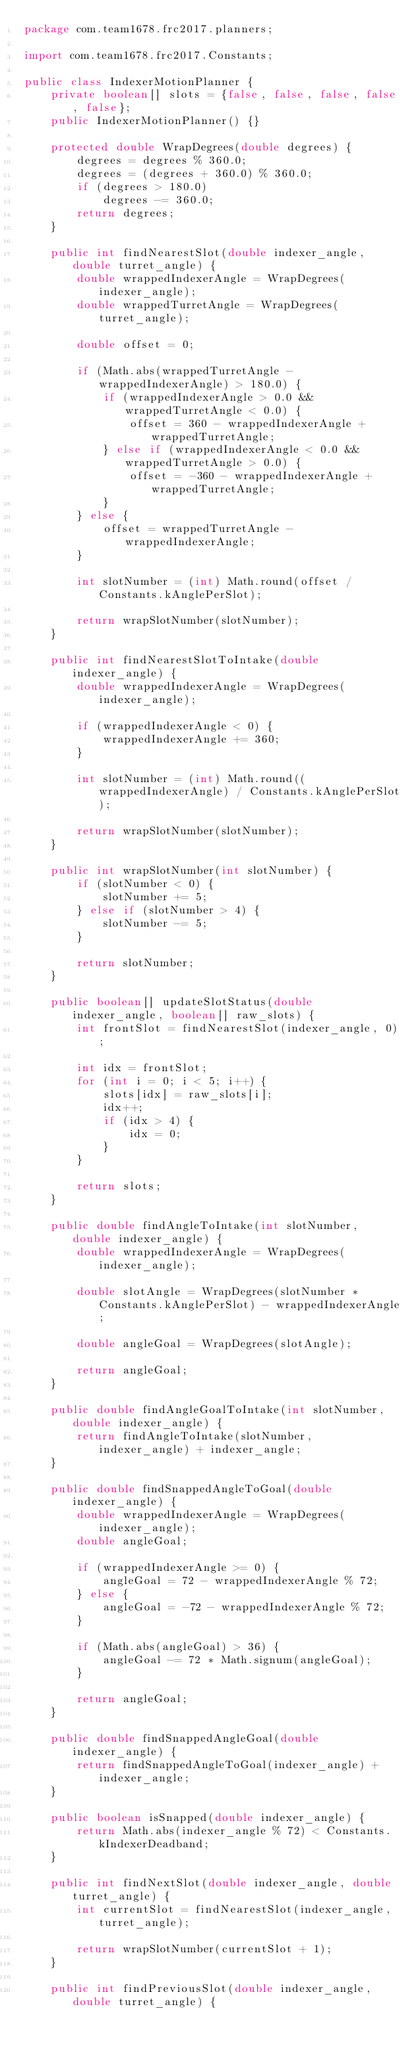Convert code to text. <code><loc_0><loc_0><loc_500><loc_500><_Java_>package com.team1678.frc2017.planners;

import com.team1678.frc2017.Constants;

public class IndexerMotionPlanner {
    private boolean[] slots = {false, false, false, false, false};
    public IndexerMotionPlanner() {}

    protected double WrapDegrees(double degrees) {
        degrees = degrees % 360.0;
        degrees = (degrees + 360.0) % 360.0;
        if (degrees > 180.0)
            degrees -= 360.0;
        return degrees;
    }

    public int findNearestSlot(double indexer_angle, double turret_angle) {
        double wrappedIndexerAngle = WrapDegrees(indexer_angle);
        double wrappedTurretAngle = WrapDegrees(turret_angle);

        double offset = 0; 
        
        if (Math.abs(wrappedTurretAngle - wrappedIndexerAngle) > 180.0) {
            if (wrappedIndexerAngle > 0.0 && wrappedTurretAngle < 0.0) {
                offset = 360 - wrappedIndexerAngle + wrappedTurretAngle;
            } else if (wrappedIndexerAngle < 0.0 && wrappedTurretAngle > 0.0) {
                offset = -360 - wrappedIndexerAngle + wrappedTurretAngle;
            }
        } else {
            offset = wrappedTurretAngle - wrappedIndexerAngle;
        }

        int slotNumber = (int) Math.round(offset / Constants.kAnglePerSlot);

        return wrapSlotNumber(slotNumber);
    }

    public int findNearestSlotToIntake(double indexer_angle) {
        double wrappedIndexerAngle = WrapDegrees(indexer_angle);

        if (wrappedIndexerAngle < 0) {
            wrappedIndexerAngle += 360;
        }

        int slotNumber = (int) Math.round((wrappedIndexerAngle) / Constants.kAnglePerSlot);

        return wrapSlotNumber(slotNumber);
    }

    public int wrapSlotNumber(int slotNumber) {
        if (slotNumber < 0) {
            slotNumber += 5;
        } else if (slotNumber > 4) {
            slotNumber -= 5;
        }

        return slotNumber;
    }

    public boolean[] updateSlotStatus(double indexer_angle, boolean[] raw_slots) {
        int frontSlot = findNearestSlot(indexer_angle, 0);

        int idx = frontSlot;
        for (int i = 0; i < 5; i++) {
            slots[idx] = raw_slots[i];
            idx++;
            if (idx > 4) {
                idx = 0;
            }
        }

        return slots;
    }

    public double findAngleToIntake(int slotNumber, double indexer_angle) {
        double wrappedIndexerAngle = WrapDegrees(indexer_angle);

        double slotAngle = WrapDegrees(slotNumber * Constants.kAnglePerSlot) - wrappedIndexerAngle;

        double angleGoal = WrapDegrees(slotAngle);

        return angleGoal;
    }

    public double findAngleGoalToIntake(int slotNumber, double indexer_angle) {
        return findAngleToIntake(slotNumber, indexer_angle) + indexer_angle;
    }

    public double findSnappedAngleToGoal(double indexer_angle) {
        double wrappedIndexerAngle = WrapDegrees(indexer_angle);
        double angleGoal;

        if (wrappedIndexerAngle >= 0) {
            angleGoal = 72 - wrappedIndexerAngle % 72;
        } else {
            angleGoal = -72 - wrappedIndexerAngle % 72;
        }

        if (Math.abs(angleGoal) > 36) {
            angleGoal -= 72 * Math.signum(angleGoal);
        }

        return angleGoal;
    }

    public double findSnappedAngleGoal(double indexer_angle) {
        return findSnappedAngleToGoal(indexer_angle) + indexer_angle;
    }

    public boolean isSnapped(double indexer_angle) {
        return Math.abs(indexer_angle % 72) < Constants.kIndexerDeadband;
    }

    public int findNextSlot(double indexer_angle, double turret_angle) {
        int currentSlot = findNearestSlot(indexer_angle, turret_angle);

        return wrapSlotNumber(currentSlot + 1);
    }

    public int findPreviousSlot(double indexer_angle, double turret_angle) {</code> 